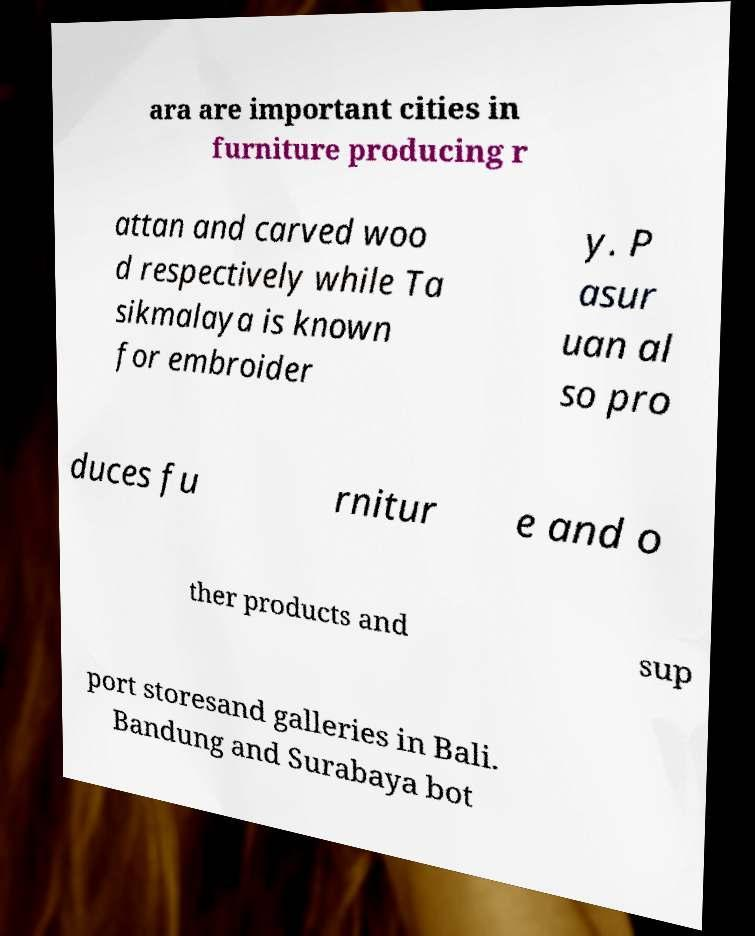I need the written content from this picture converted into text. Can you do that? ara are important cities in furniture producing r attan and carved woo d respectively while Ta sikmalaya is known for embroider y. P asur uan al so pro duces fu rnitur e and o ther products and sup port storesand galleries in Bali. Bandung and Surabaya bot 